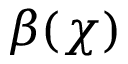<formula> <loc_0><loc_0><loc_500><loc_500>\beta ( \chi )</formula> 